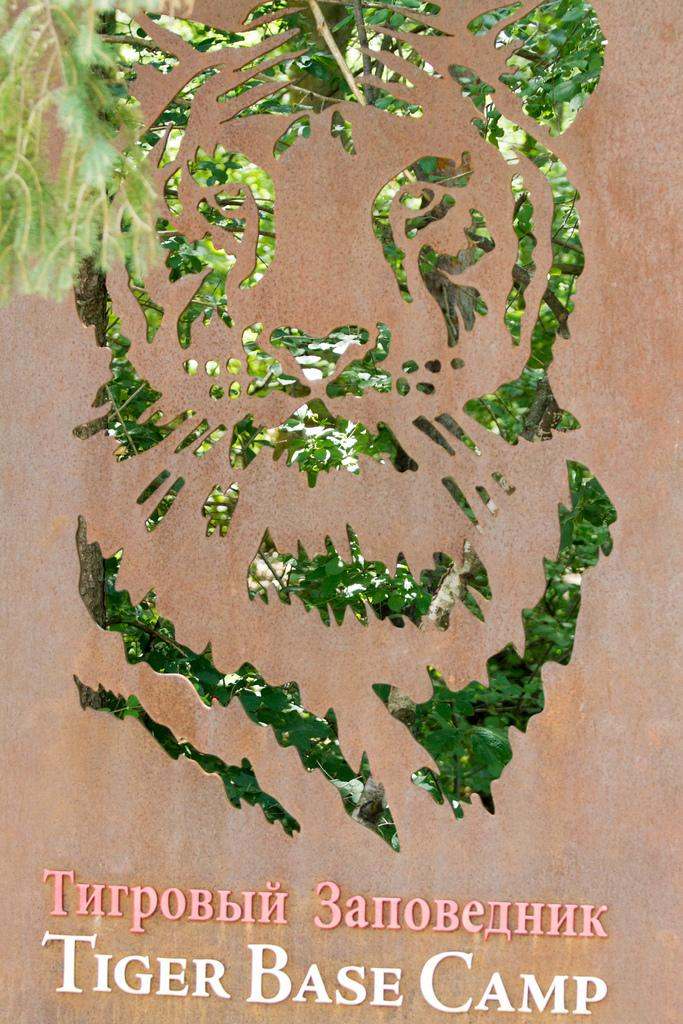What is featured in the image? There is a poster in the image. What is depicted on the poster? The poster contains a picture of an animal made from green leaves. Is there any text on the poster? Yes, there is text on the poster. What type of bridge is visible in the image? There is no bridge present in the image; it features a poster with a picture of an animal made from green leaves and text. 